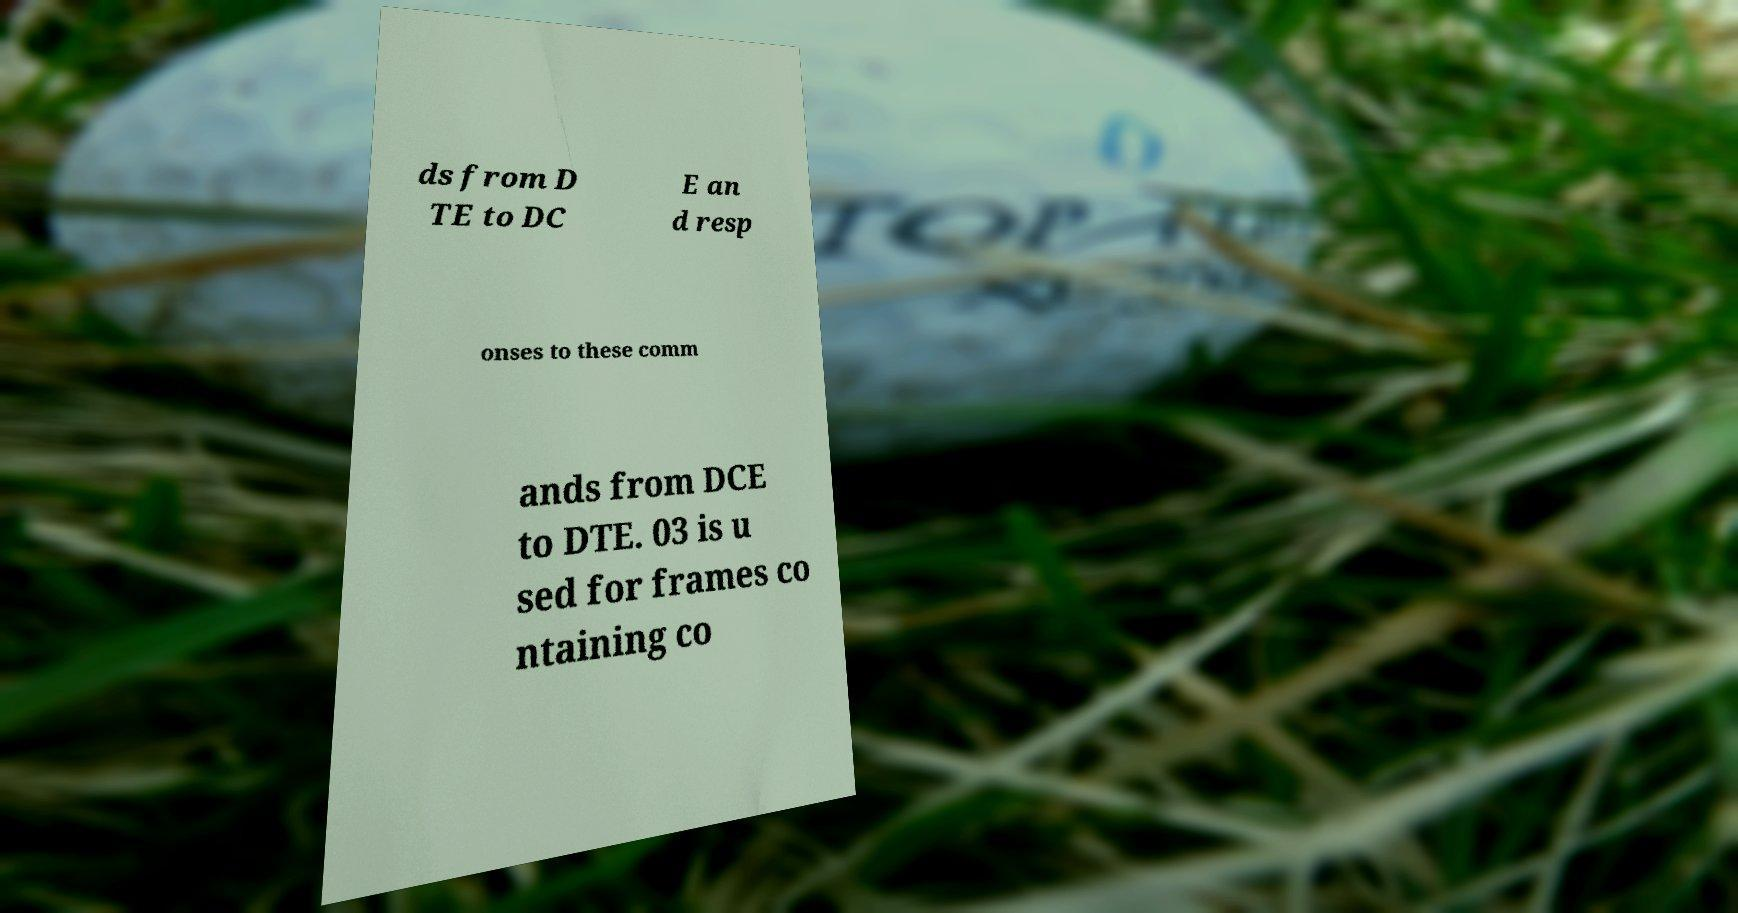Could you extract and type out the text from this image? ds from D TE to DC E an d resp onses to these comm ands from DCE to DTE. 03 is u sed for frames co ntaining co 